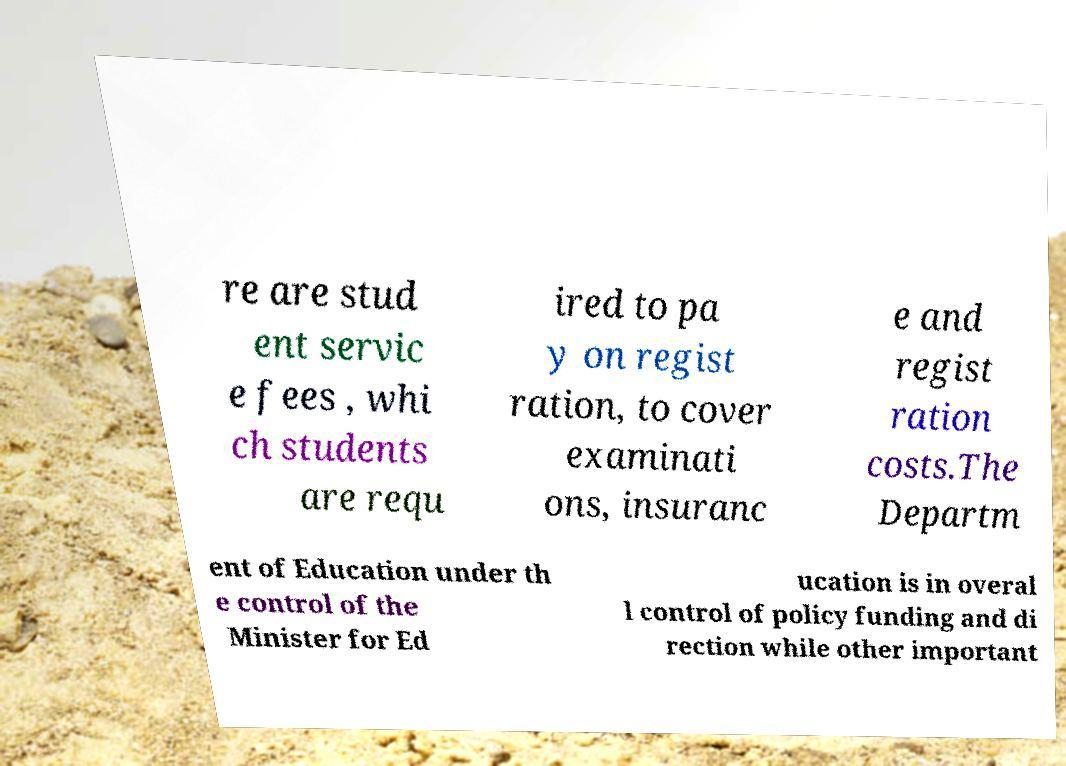Please read and relay the text visible in this image. What does it say? re are stud ent servic e fees , whi ch students are requ ired to pa y on regist ration, to cover examinati ons, insuranc e and regist ration costs.The Departm ent of Education under th e control of the Minister for Ed ucation is in overal l control of policy funding and di rection while other important 